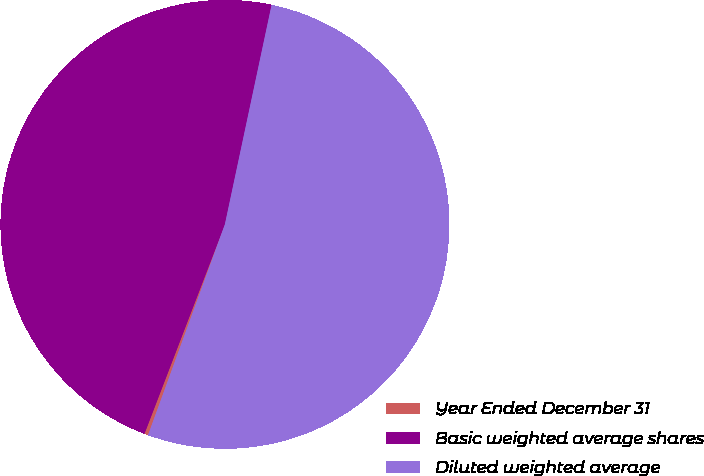<chart> <loc_0><loc_0><loc_500><loc_500><pie_chart><fcel>Year Ended December 31<fcel>Basic weighted average shares<fcel>Diluted weighted average<nl><fcel>0.27%<fcel>47.5%<fcel>52.23%<nl></chart> 